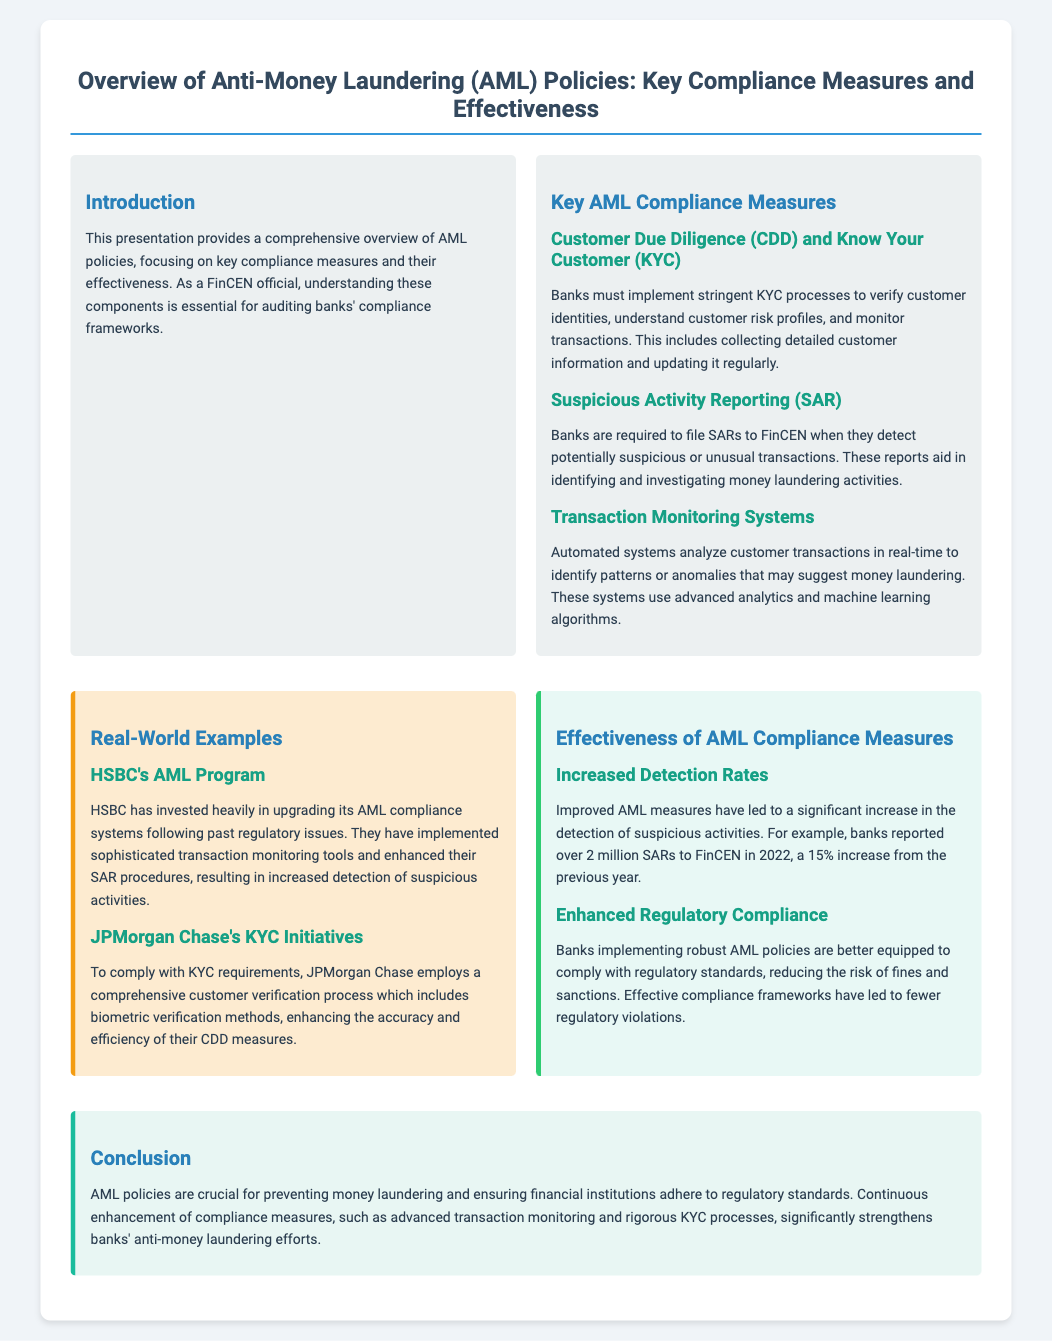What is the title of the presentation? The title of the presentation is explicitly stated at the top of the slide.
Answer: Overview of Anti-Money Laundering (AML) Policies: Key Compliance Measures and Effectiveness What does CDD stand for? CDD is an abbreviation mentioned as part of the key AML compliance measures, related to customer processes.
Answer: Customer Due Diligence How many SARs were reported to FinCEN in 2022? This information is provided under the effectiveness section, detailing the increase over the previous year.
Answer: over 2 million What is the percentage increase of SARs reported from the previous year? The increase percentage is given as part of the statistics of SAR reporting.
Answer: 15% Which bank invested heavily in upgrading its AML compliance systems? The document gives a real-world example highlighting HSBC's efforts in AML compliance.
Answer: HSBC What is one method used for biometric verification in JPMorgan Chase's KYC initiatives? The document mentions that JPMorgan Chase employs a comprehensive verification process including biometric verification.
Answer: Biometric verification What color represents the effectiveness section in the slide? The specific color used for each section is noted in the document's style guidelines.
Answer: Light green What is the main conclusion drawn in the presentation? The conclusion section summarizes the importance of AML policies and their enhancement in preventing money laundering.
Answer: Continuous enhancement of compliance measures 